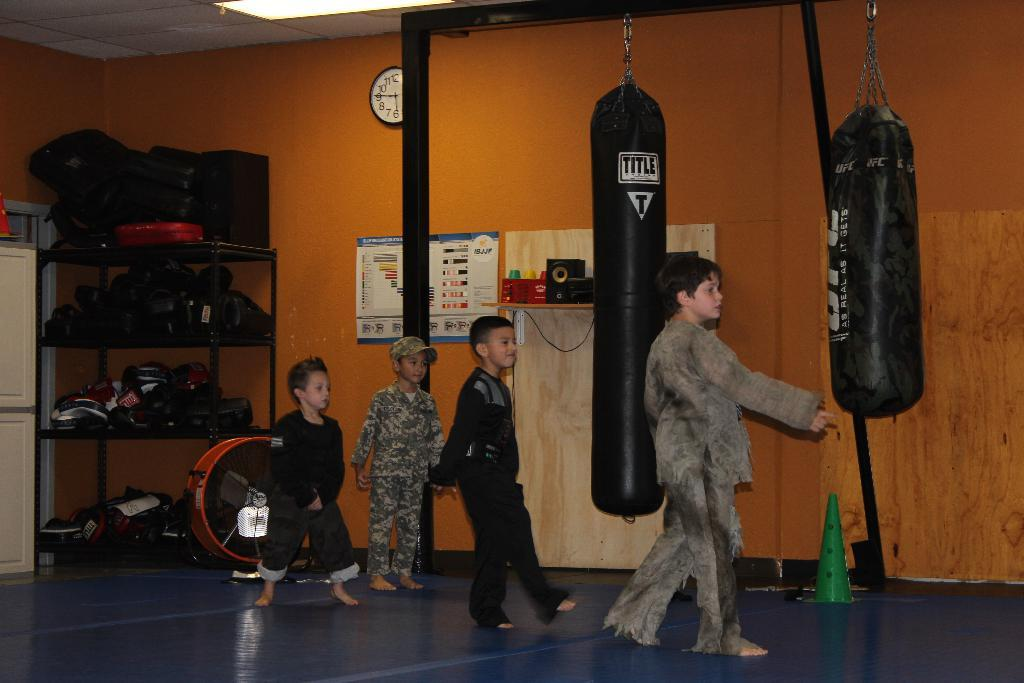Who is present in the image? There are children in the image. Where are the children located? The children are on the floor. What can be seen in the background of the image? There is a wall, a clock, punching bags, a poster, and some objects in the background of the image. What type of shoe polish is being used by the children in the image? There is no shoe polish present in the image; the children are on the floor and there are no shoes or polishing activities depicted. 